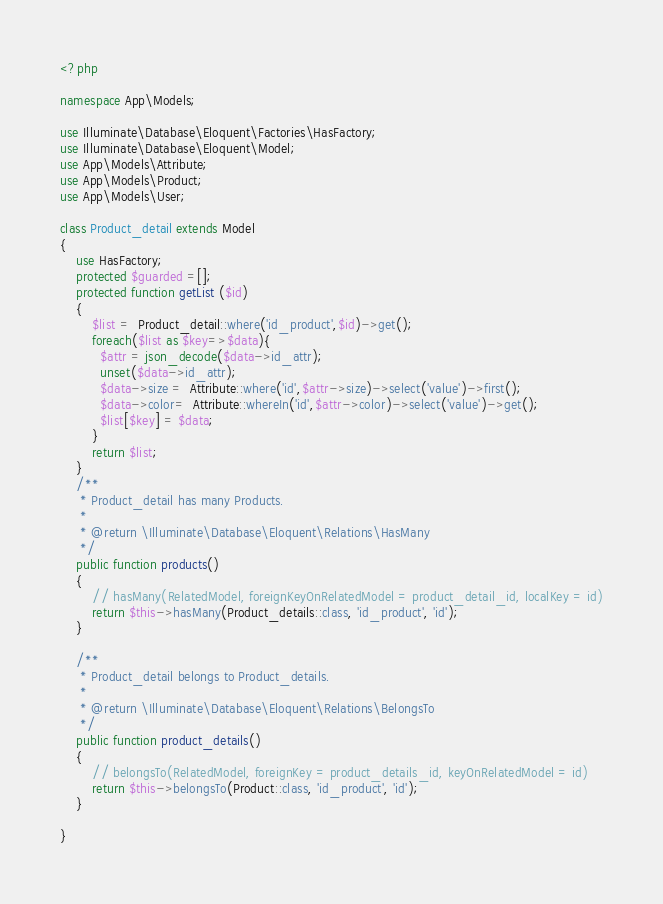<code> <loc_0><loc_0><loc_500><loc_500><_PHP_><?php

namespace App\Models;

use Illuminate\Database\Eloquent\Factories\HasFactory;
use Illuminate\Database\Eloquent\Model;
use App\Models\Attribute;
use App\Models\Product;
use App\Models\User;

class Product_detail extends Model
{
    use HasFactory;
    protected $guarded =[];
    protected function getList ($id)
    {
        $list =  Product_detail::where('id_product',$id)->get();
        foreach($list as $key=>$data){
          $attr = json_decode($data->id_attr);
          unset($data->id_attr);
          $data->size =  Attribute::where('id',$attr->size)->select('value')->first();
          $data->color=  Attribute::whereIn('id',$attr->color)->select('value')->get();
          $list[$key] = $data;
        }
        return $list;
    }
    /**
     * Product_detail has many Products.
     *
     * @return \Illuminate\Database\Eloquent\Relations\HasMany
     */
    public function products()
    {
        // hasMany(RelatedModel, foreignKeyOnRelatedModel = product_detail_id, localKey = id)
        return $this->hasMany(Product_details::class, 'id_product', 'id');
    }

    /**
     * Product_detail belongs to Product_details.
     *
     * @return \Illuminate\Database\Eloquent\Relations\BelongsTo
     */
    public function product_details()
    {
        // belongsTo(RelatedModel, foreignKey = product_details_id, keyOnRelatedModel = id)
        return $this->belongsTo(Product::class, 'id_product', 'id');
    }

}
</code> 